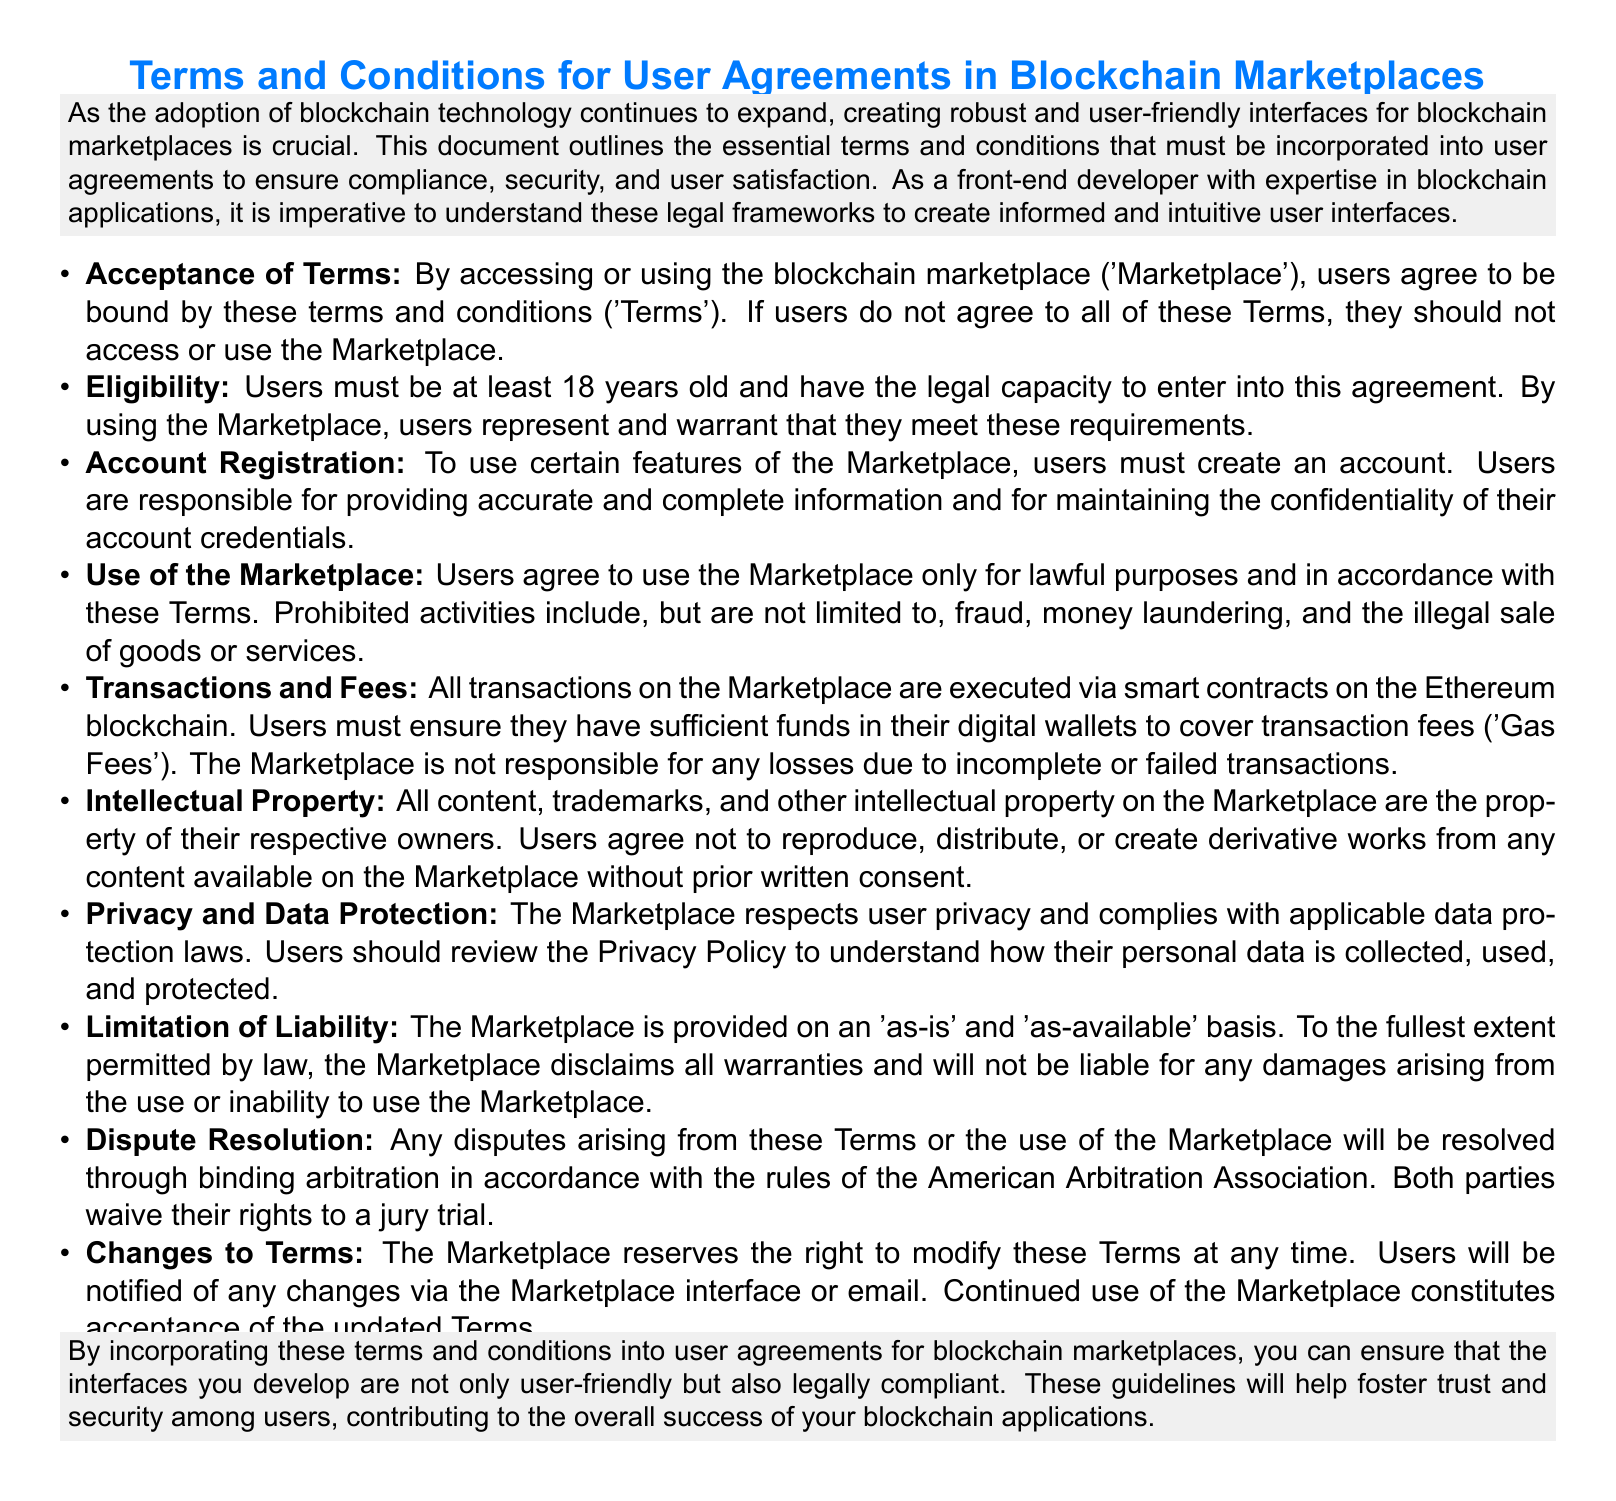What must users do to access the Marketplace? Users must agree to be bound by the terms and conditions.
Answer: Agree to the terms What is the minimum age requirement for users? Users must be at least 18 years old to access the Marketplace.
Answer: 18 years old What is required to use certain features of the Marketplace? Users must create an account to use certain features.
Answer: Create an account What are users required to have in their digital wallets? Users must have sufficient funds to cover transaction fees.
Answer: Sufficient funds How are transactions executed on the Marketplace? Transactions are executed via smart contracts on the Ethereum blockchain.
Answer: Smart contracts What type of property is protected under the Intellectual Property section? All content, trademarks, and other intellectual property.
Answer: All content, trademarks, and other intellectual property What does the Marketplace disclaim under the Limitation of Liability section? The Marketplace disclaims all warranties.
Answer: All warranties What method is used for dispute resolution? Disputes are resolved through binding arbitration.
Answer: Binding arbitration What must users do to accept updated Terms? Continued use of the Marketplace constitutes acceptance.
Answer: Continued use 